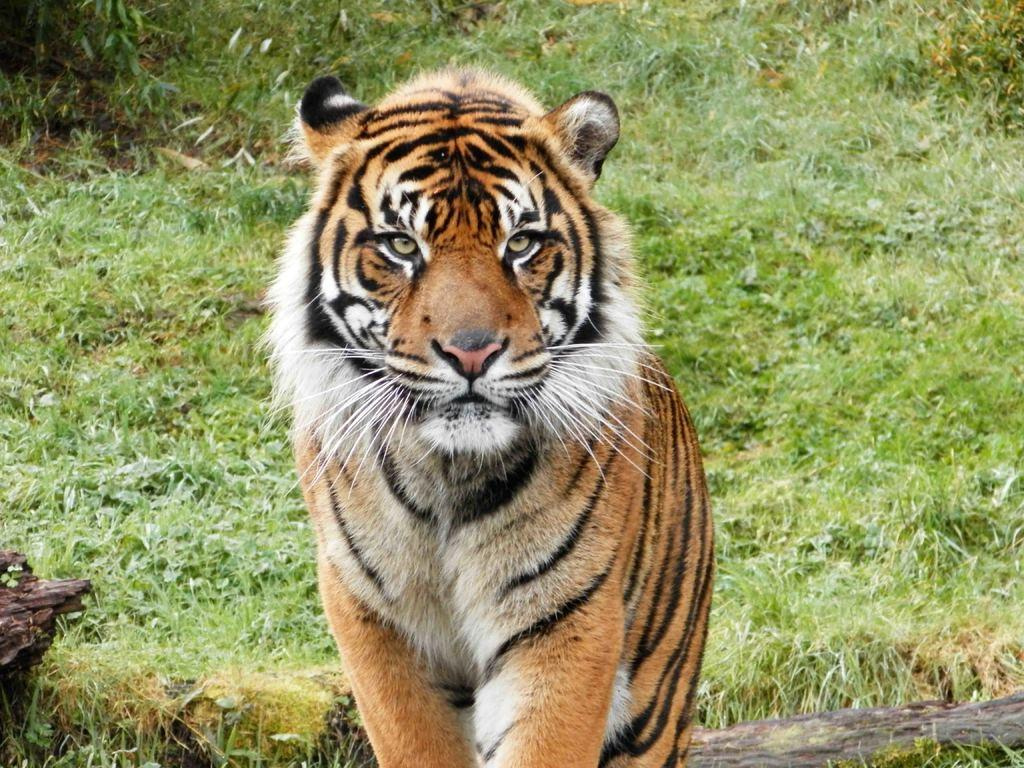What animal is the main subject of the picture? There is a tiger in the picture. What is the tiger doing in the image? The tiger is sitting on the ground. What type of environment can be seen in the background of the image? There is grass visible in the background of the image. What brand of toothpaste is the tiger using in the image? There is no toothpaste present in the image, and the tiger is not using any toothpaste. What type of prose is being written by the tiger in the image? There is no writing or prose present in the image, and the tiger is not engaged in any writing activity. 